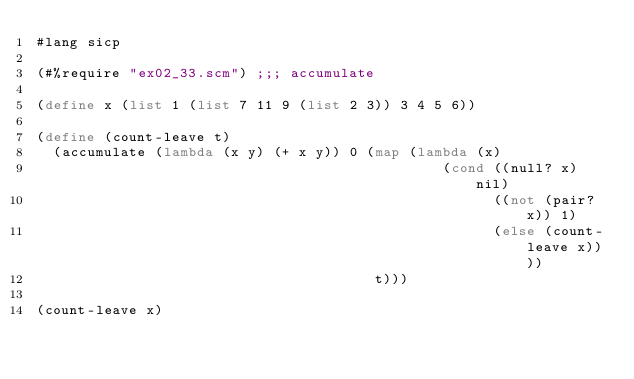Convert code to text. <code><loc_0><loc_0><loc_500><loc_500><_Scheme_>#lang sicp

(#%require "ex02_33.scm") ;;; accumulate

(define x (list 1 (list 7 11 9 (list 2 3)) 3 4 5 6))

(define (count-leave t)
  (accumulate (lambda (x y) (+ x y)) 0 (map (lambda (x) 
                                                (cond ((null? x) nil)
                                                      ((not (pair? x)) 1)
                                                      (else (count-leave x))))
                                        t)))                                                         
  
(count-leave x)</code> 